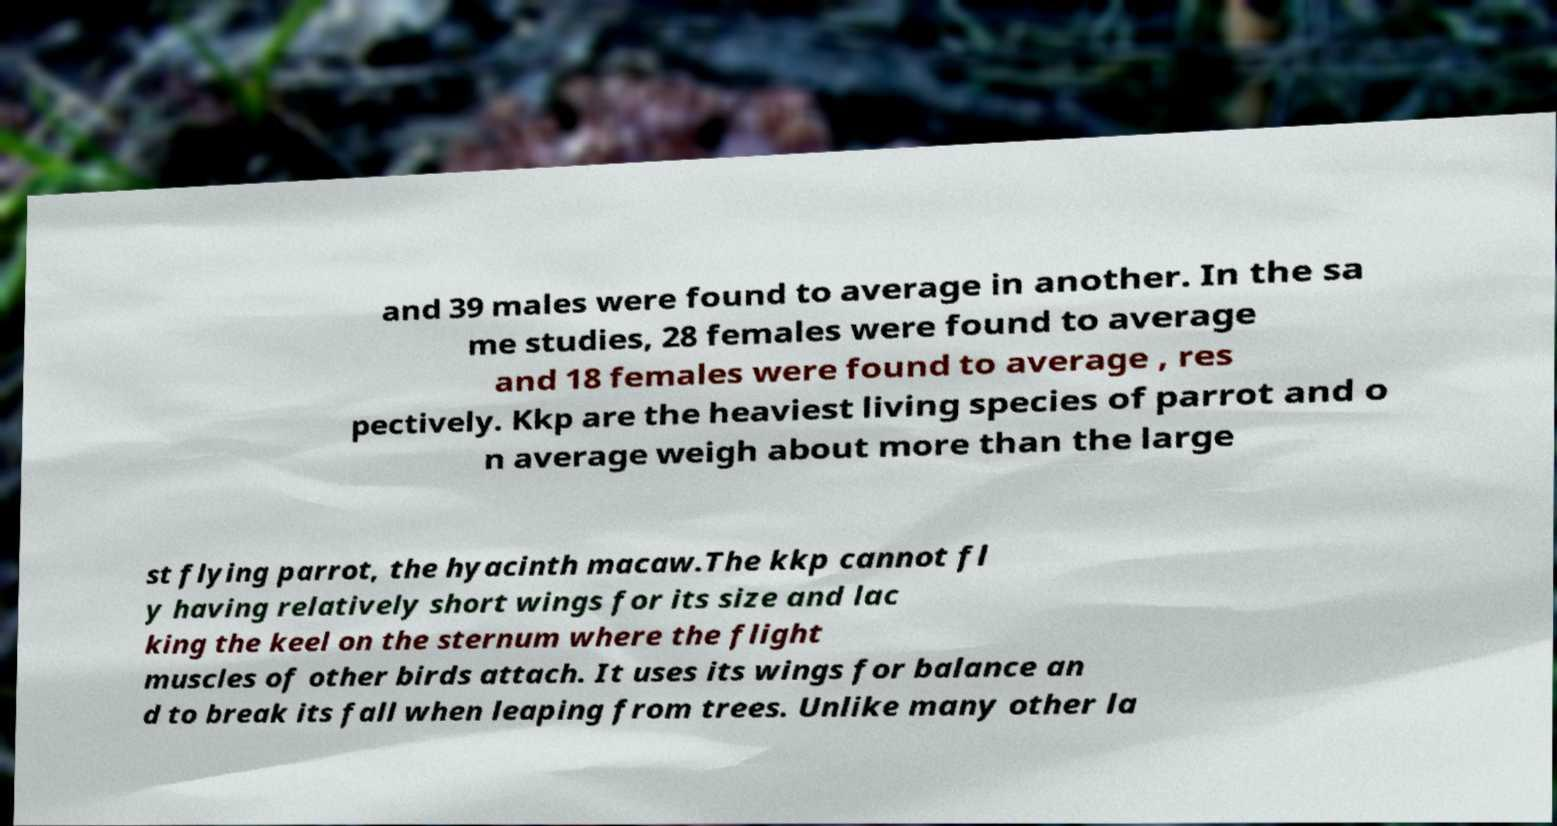Can you read and provide the text displayed in the image?This photo seems to have some interesting text. Can you extract and type it out for me? and 39 males were found to average in another. In the sa me studies, 28 females were found to average and 18 females were found to average , res pectively. Kkp are the heaviest living species of parrot and o n average weigh about more than the large st flying parrot, the hyacinth macaw.The kkp cannot fl y having relatively short wings for its size and lac king the keel on the sternum where the flight muscles of other birds attach. It uses its wings for balance an d to break its fall when leaping from trees. Unlike many other la 